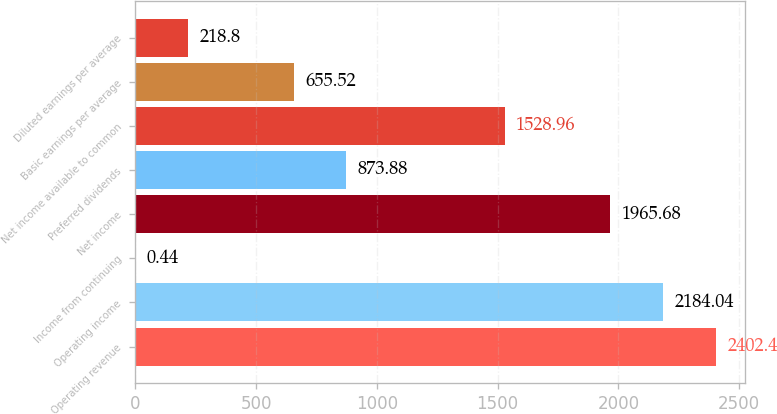<chart> <loc_0><loc_0><loc_500><loc_500><bar_chart><fcel>Operating revenue<fcel>Operating income<fcel>Income from continuing<fcel>Net income<fcel>Preferred dividends<fcel>Net income available to common<fcel>Basic earnings per average<fcel>Diluted earnings per average<nl><fcel>2402.4<fcel>2184.04<fcel>0.44<fcel>1965.68<fcel>873.88<fcel>1528.96<fcel>655.52<fcel>218.8<nl></chart> 